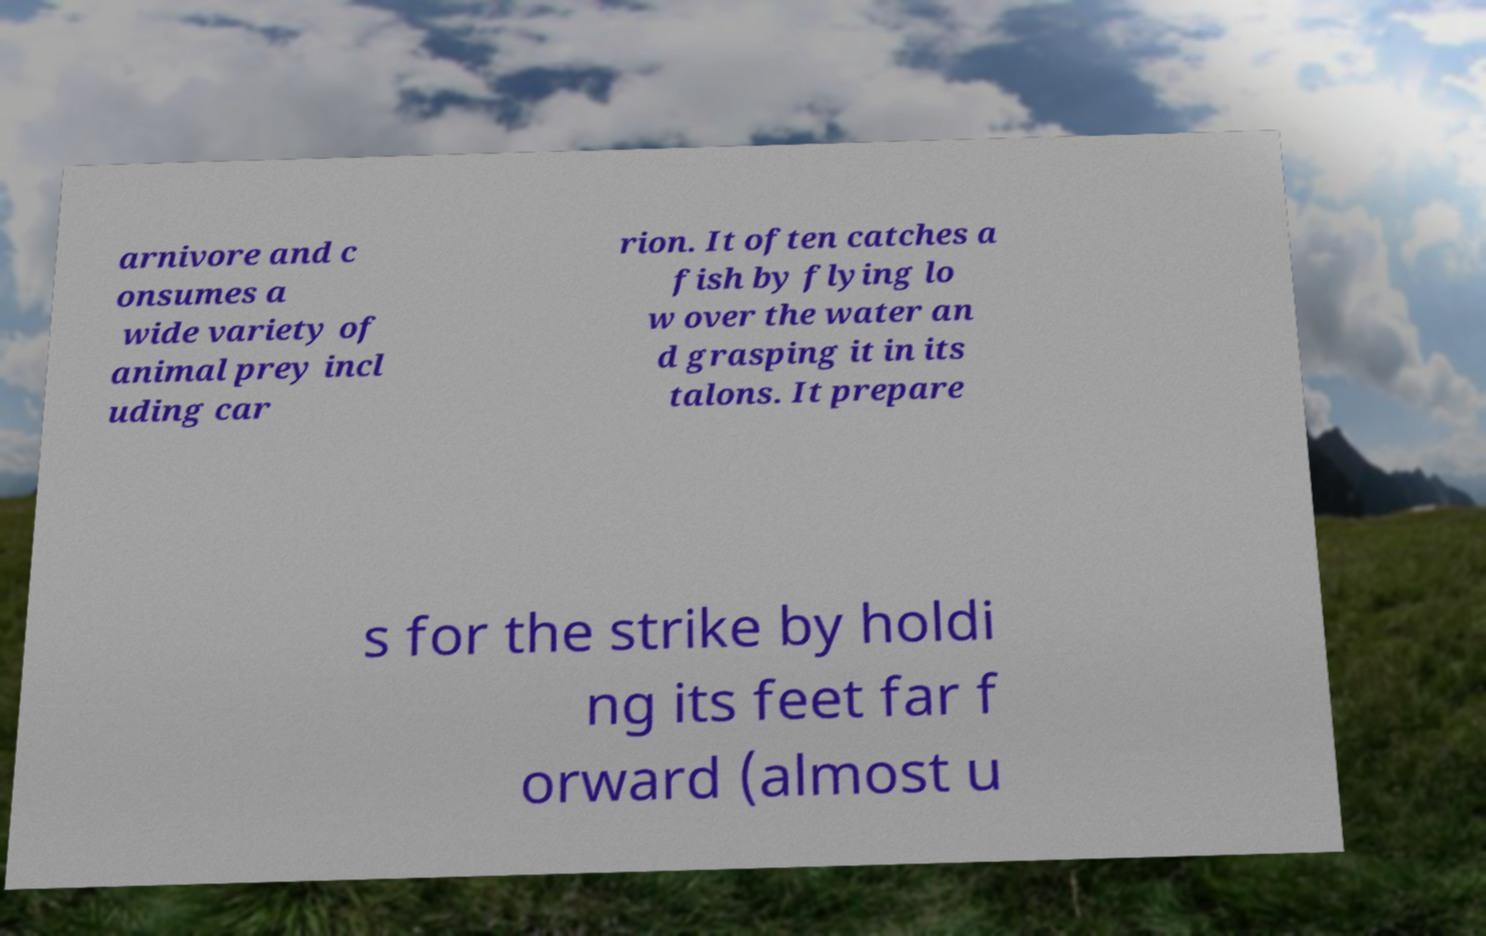For documentation purposes, I need the text within this image transcribed. Could you provide that? arnivore and c onsumes a wide variety of animal prey incl uding car rion. It often catches a fish by flying lo w over the water an d grasping it in its talons. It prepare s for the strike by holdi ng its feet far f orward (almost u 